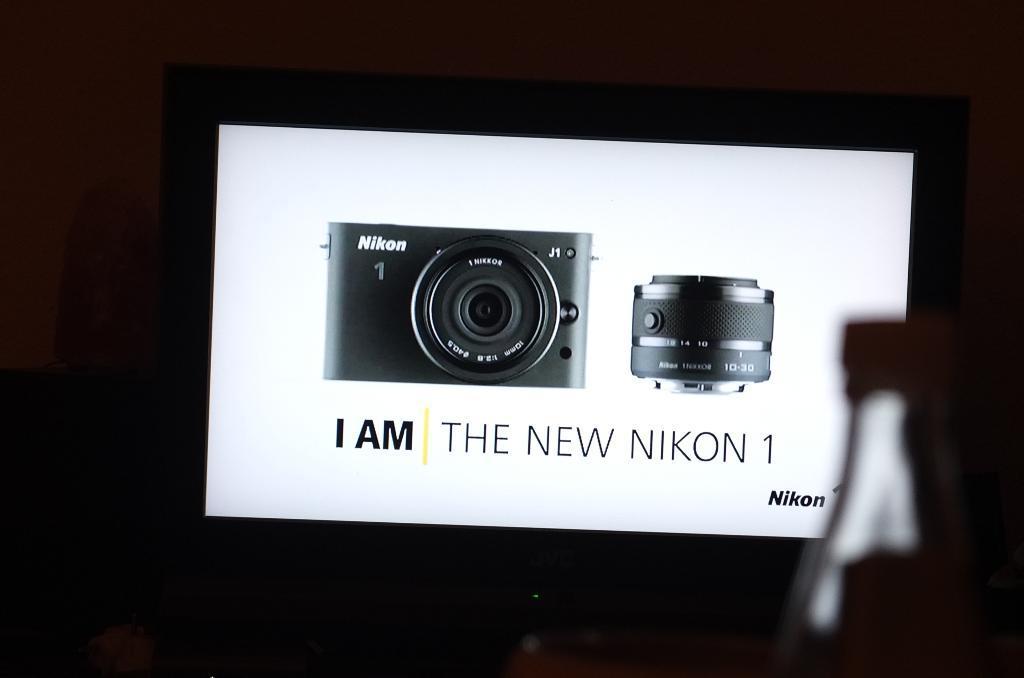How would you summarize this image in a sentence or two? In the image the pictures of camera and lens are being displaying on the screen. 